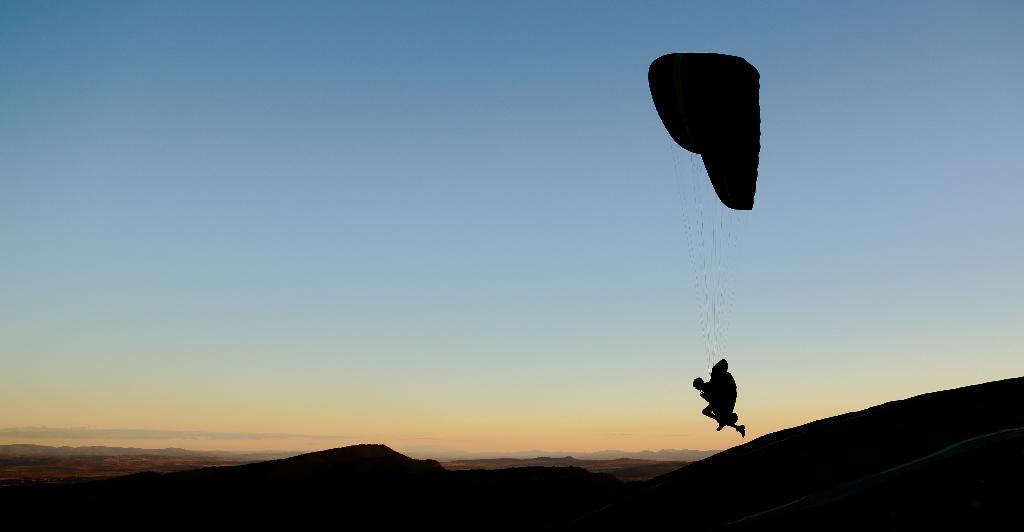What object is located on the right side of the image? There is a parachute on the right side of the image. What type of landscape can be seen at the bottom of the image? There are hills at the bottom of the image. What is visible in the background of the image? The sky is visible in the background of the image. What type of yoke is being used by the parachute in the image? There is no yoke present in the image, as parachutes do not typically use yokes. What country is the parachute originating from in the image? The image does not provide any information about the country of origin for the parachute. 